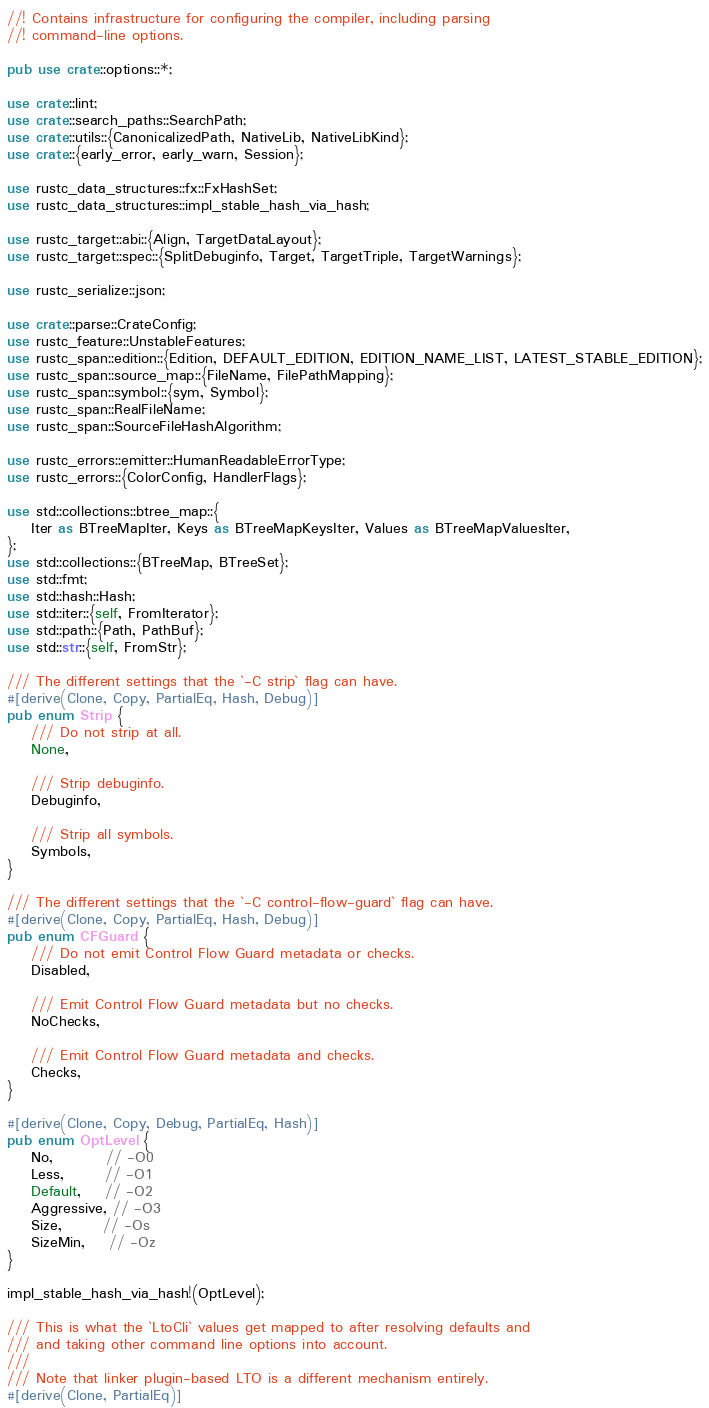Convert code to text. <code><loc_0><loc_0><loc_500><loc_500><_Rust_>//! Contains infrastructure for configuring the compiler, including parsing
//! command-line options.

pub use crate::options::*;

use crate::lint;
use crate::search_paths::SearchPath;
use crate::utils::{CanonicalizedPath, NativeLib, NativeLibKind};
use crate::{early_error, early_warn, Session};

use rustc_data_structures::fx::FxHashSet;
use rustc_data_structures::impl_stable_hash_via_hash;

use rustc_target::abi::{Align, TargetDataLayout};
use rustc_target::spec::{SplitDebuginfo, Target, TargetTriple, TargetWarnings};

use rustc_serialize::json;

use crate::parse::CrateConfig;
use rustc_feature::UnstableFeatures;
use rustc_span::edition::{Edition, DEFAULT_EDITION, EDITION_NAME_LIST, LATEST_STABLE_EDITION};
use rustc_span::source_map::{FileName, FilePathMapping};
use rustc_span::symbol::{sym, Symbol};
use rustc_span::RealFileName;
use rustc_span::SourceFileHashAlgorithm;

use rustc_errors::emitter::HumanReadableErrorType;
use rustc_errors::{ColorConfig, HandlerFlags};

use std::collections::btree_map::{
    Iter as BTreeMapIter, Keys as BTreeMapKeysIter, Values as BTreeMapValuesIter,
};
use std::collections::{BTreeMap, BTreeSet};
use std::fmt;
use std::hash::Hash;
use std::iter::{self, FromIterator};
use std::path::{Path, PathBuf};
use std::str::{self, FromStr};

/// The different settings that the `-C strip` flag can have.
#[derive(Clone, Copy, PartialEq, Hash, Debug)]
pub enum Strip {
    /// Do not strip at all.
    None,

    /// Strip debuginfo.
    Debuginfo,

    /// Strip all symbols.
    Symbols,
}

/// The different settings that the `-C control-flow-guard` flag can have.
#[derive(Clone, Copy, PartialEq, Hash, Debug)]
pub enum CFGuard {
    /// Do not emit Control Flow Guard metadata or checks.
    Disabled,

    /// Emit Control Flow Guard metadata but no checks.
    NoChecks,

    /// Emit Control Flow Guard metadata and checks.
    Checks,
}

#[derive(Clone, Copy, Debug, PartialEq, Hash)]
pub enum OptLevel {
    No,         // -O0
    Less,       // -O1
    Default,    // -O2
    Aggressive, // -O3
    Size,       // -Os
    SizeMin,    // -Oz
}

impl_stable_hash_via_hash!(OptLevel);

/// This is what the `LtoCli` values get mapped to after resolving defaults and
/// and taking other command line options into account.
///
/// Note that linker plugin-based LTO is a different mechanism entirely.
#[derive(Clone, PartialEq)]</code> 